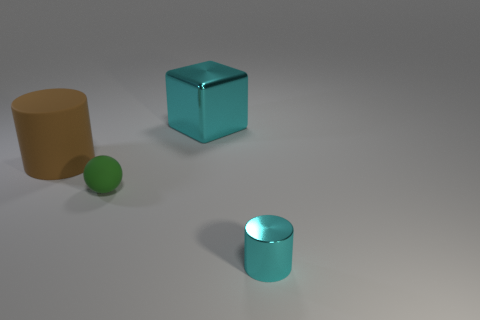Add 1 cyan metallic blocks. How many objects exist? 5 Subtract all cubes. How many objects are left? 3 Subtract 0 yellow cylinders. How many objects are left? 4 Subtract all tiny blue things. Subtract all cylinders. How many objects are left? 2 Add 1 brown matte things. How many brown matte things are left? 2 Add 1 brown matte objects. How many brown matte objects exist? 2 